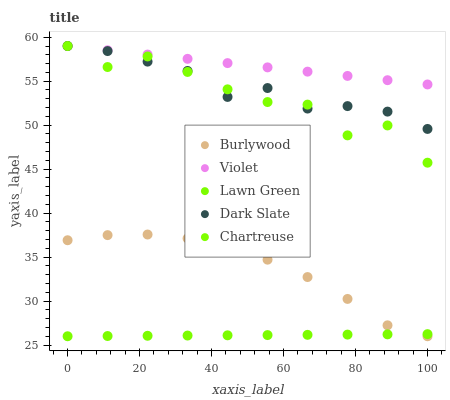Does Lawn Green have the minimum area under the curve?
Answer yes or no. Yes. Does Violet have the maximum area under the curve?
Answer yes or no. Yes. Does Chartreuse have the minimum area under the curve?
Answer yes or no. No. Does Chartreuse have the maximum area under the curve?
Answer yes or no. No. Is Lawn Green the smoothest?
Answer yes or no. Yes. Is Chartreuse the roughest?
Answer yes or no. Yes. Is Chartreuse the smoothest?
Answer yes or no. No. Is Lawn Green the roughest?
Answer yes or no. No. Does Burlywood have the lowest value?
Answer yes or no. Yes. Does Chartreuse have the lowest value?
Answer yes or no. No. Does Violet have the highest value?
Answer yes or no. Yes. Does Lawn Green have the highest value?
Answer yes or no. No. Is Burlywood less than Chartreuse?
Answer yes or no. Yes. Is Chartreuse greater than Burlywood?
Answer yes or no. Yes. Does Dark Slate intersect Chartreuse?
Answer yes or no. Yes. Is Dark Slate less than Chartreuse?
Answer yes or no. No. Is Dark Slate greater than Chartreuse?
Answer yes or no. No. Does Burlywood intersect Chartreuse?
Answer yes or no. No. 